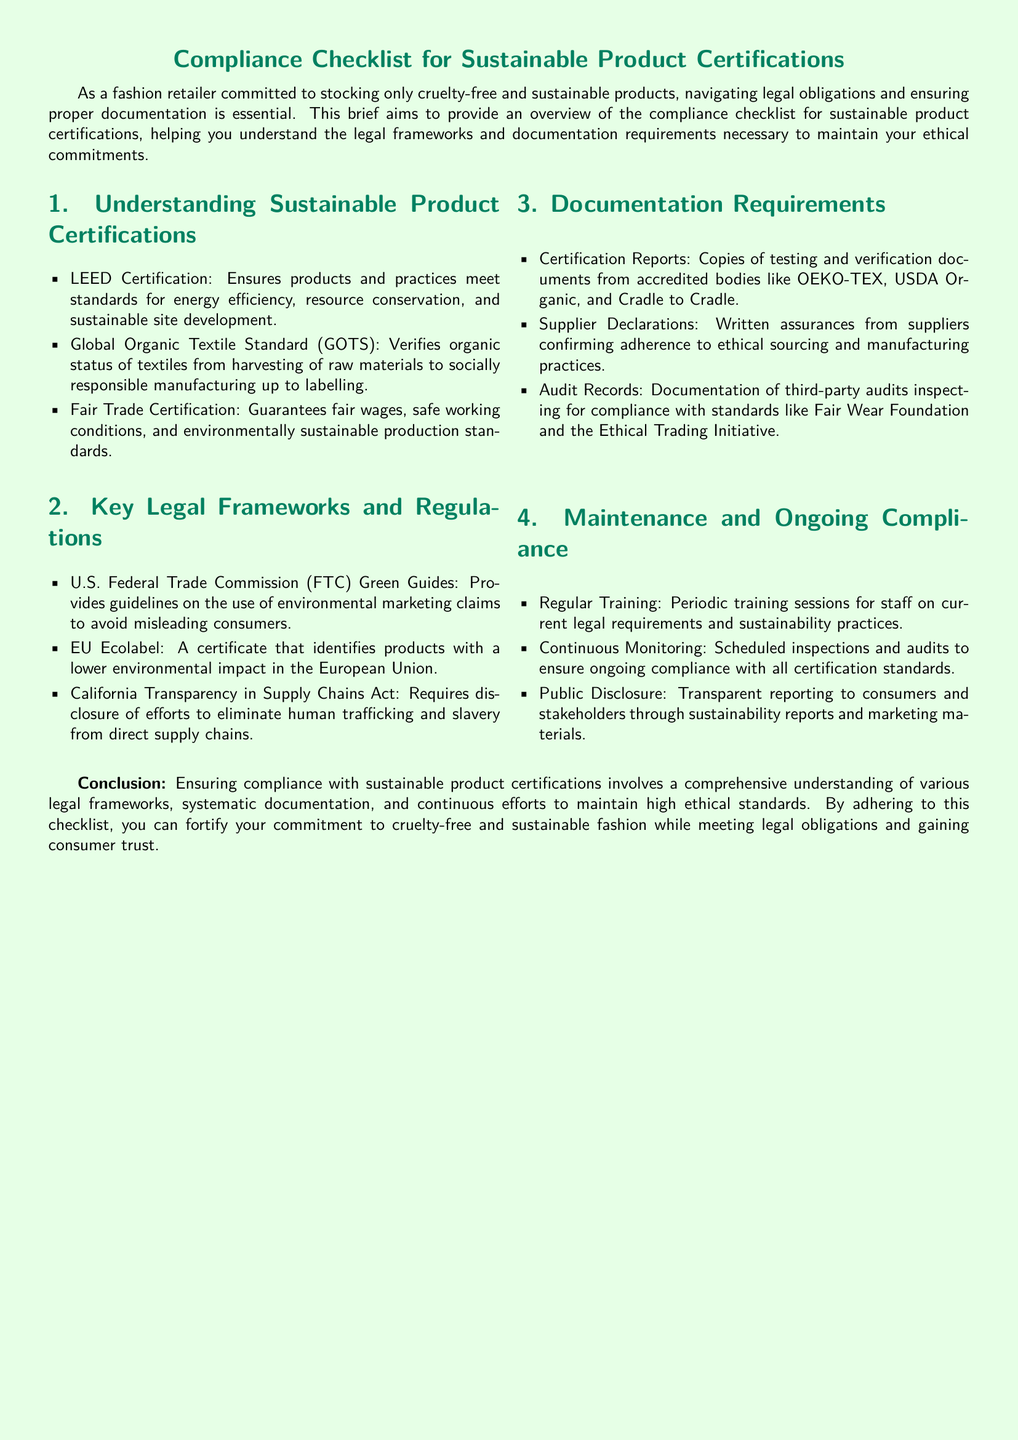What is LEED Certification? LEED Certification is one of the sustainable product certifications that ensures products and practices meet standards for energy efficiency, resource conservation, and sustainable site development.
Answer: Ensures energy efficiency What does GOTS stand for? GOTS stands for Global Organic Textile Standard, which verifies organic status of textiles from harvesting to labelling.
Answer: Global Organic Textile Standard Which organization provides guidelines on environmental marketing claims? The U.S. Federal Trade Commission (FTC) provides guidelines on the use of environmental marketing claims to avoid misleading consumers.
Answer: U.S. Federal Trade Commission What is required by the California Transparency in Supply Chains Act? The California Transparency in Supply Chains Act requires disclosure of efforts to eliminate human trafficking and slavery from direct supply chains.
Answer: Disclosure of human trafficking efforts What type of documentation includes Certified Reports? Certification Reports encompass copies of testing and verification documents from accredited bodies like OEKO-TEX and USDA Organic.
Answer: Copies of testing and verification documents What kind of sessions should be conducted for staff? Regular training sessions should be conducted for staff on current legal requirements and sustainability practices.
Answer: Periodic training sessions What is the purpose of audit records? Audit Records serve to document third-party audits inspecting for compliance with standards like Fair Wear Foundation and the Ethical Trading Initiative.
Answer: Document compliance with standards What is necessary for ongoing compliance? Continuous monitoring through scheduled inspections and audits is necessary for ongoing compliance with all certification standards.
Answer: Scheduled inspections and audits What is the main focus of the compliance checklist? The main focus of the compliance checklist is to provide an overview of compliance for sustainable product certifications and to understand legal frameworks.
Answer: Overview of compliance for sustainable product certifications 